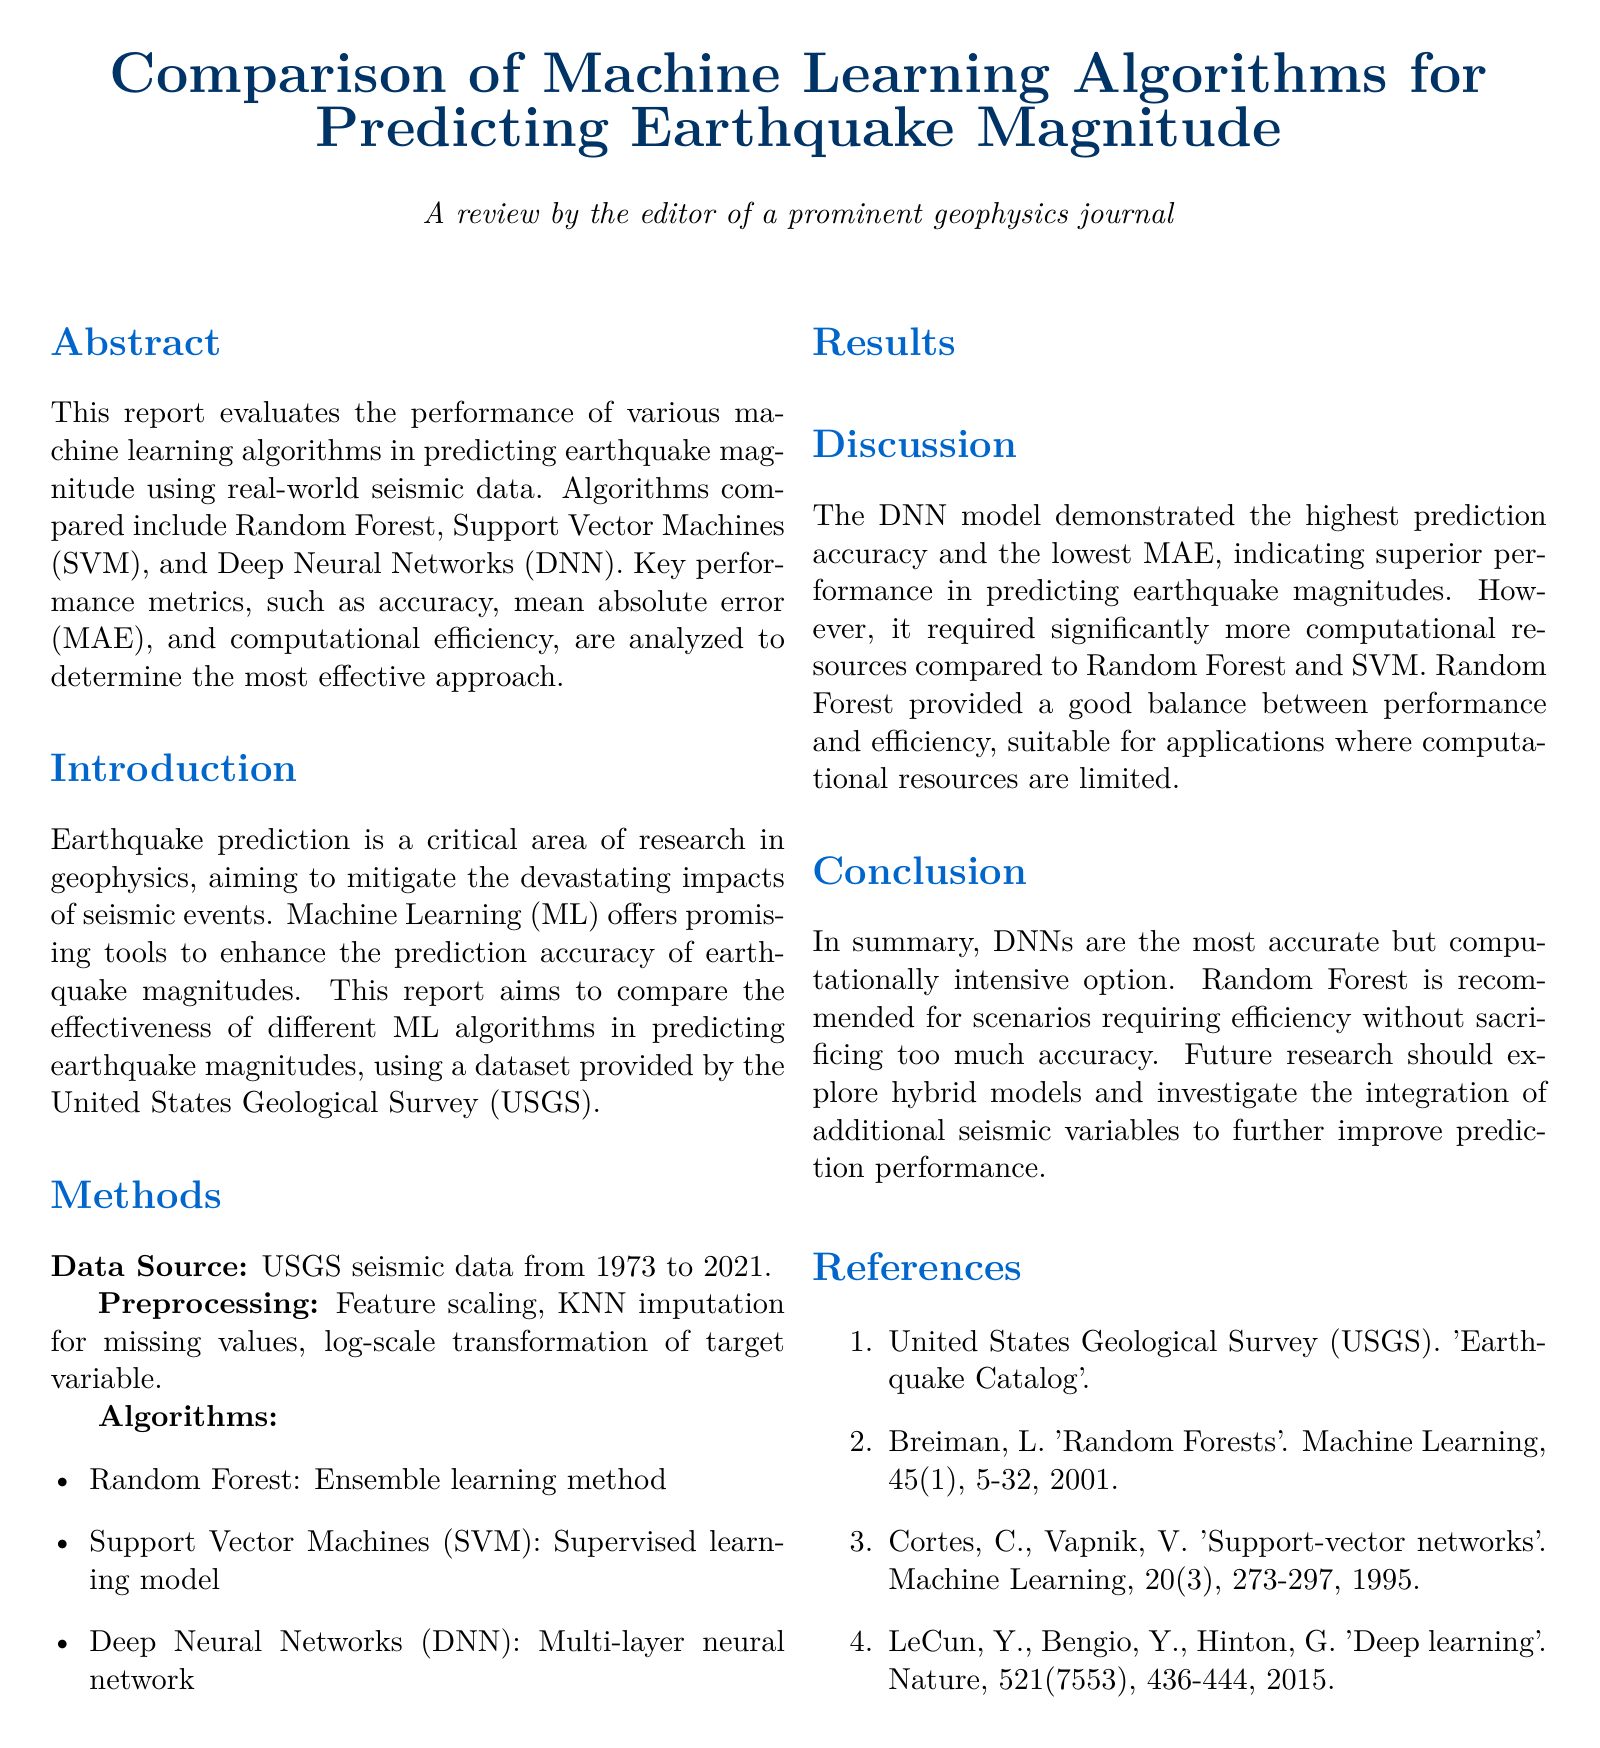What is the title of the report? The title of the report is described in the title section of the document.
Answer: Comparison of Machine Learning Algorithms for Predicting Earthquake Magnitude What is the main data source used for the study? The main data source for the study is mentioned in the Methods section of the document.
Answer: USGS seismic data from 1973 to 2021 Which algorithm demonstrated the highest accuracy? Accuracy for each algorithm is presented in the Results section of the document.
Answer: Deep Neural Networks What does MAE stand for? MAE is defined within the context of the report and stands for mean absolute error.
Answer: Mean Absolute Error Which algorithm has the highest computational efficiency? The comparison of computational efficiency is provided in the Results section, indicating which algorithm is the most efficient.
Answer: Random Forest What is the recommended algorithm for scenarios requiring efficiency? The conclusion provides recommendations about algorithms based on efficiency.
Answer: Random Forest What year did the study use data until? The time frame of the USGS data is stated in the Methods section of the document, highlighting the range of years.
Answer: 2021 How many references are included in the report? The number of references is indicated at the end of the document in the References section.
Answer: 4 